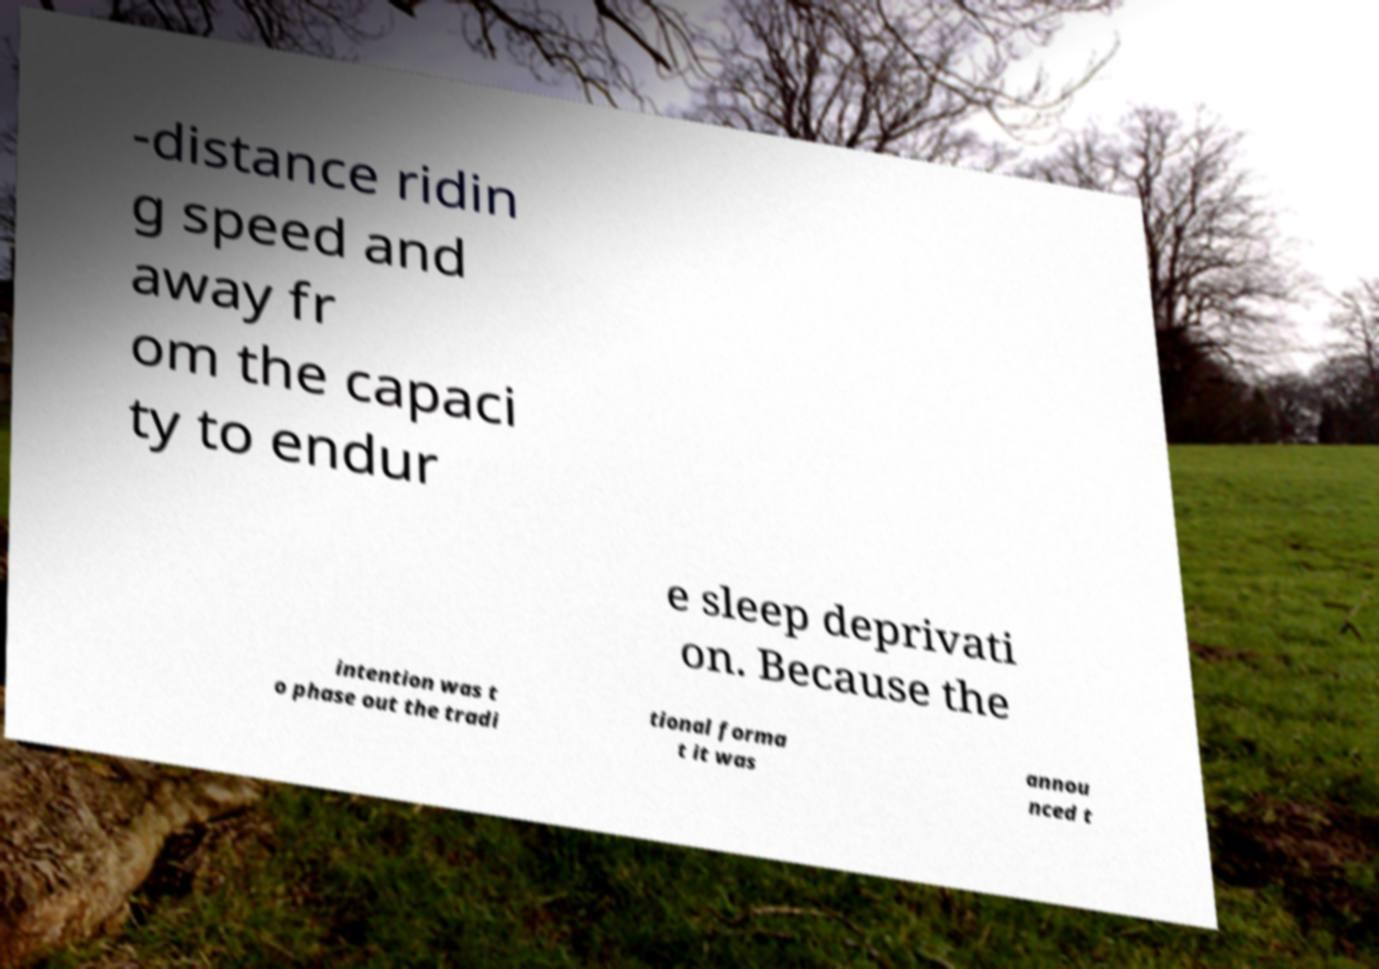For documentation purposes, I need the text within this image transcribed. Could you provide that? -distance ridin g speed and away fr om the capaci ty to endur e sleep deprivati on. Because the intention was t o phase out the tradi tional forma t it was annou nced t 